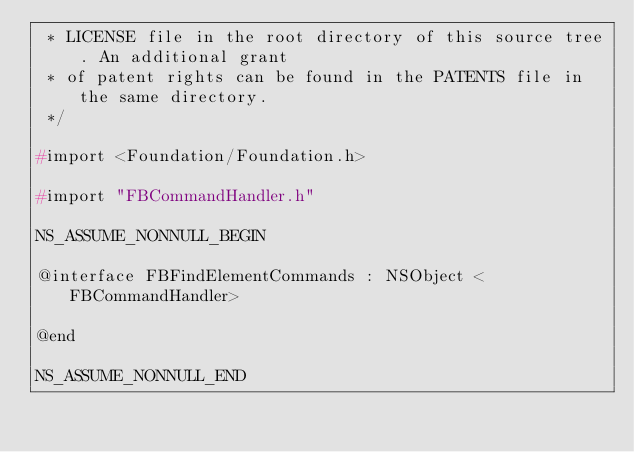Convert code to text. <code><loc_0><loc_0><loc_500><loc_500><_C_> * LICENSE file in the root directory of this source tree. An additional grant
 * of patent rights can be found in the PATENTS file in the same directory.
 */

#import <Foundation/Foundation.h>

#import "FBCommandHandler.h"

NS_ASSUME_NONNULL_BEGIN

@interface FBFindElementCommands : NSObject <FBCommandHandler>

@end

NS_ASSUME_NONNULL_END
</code> 